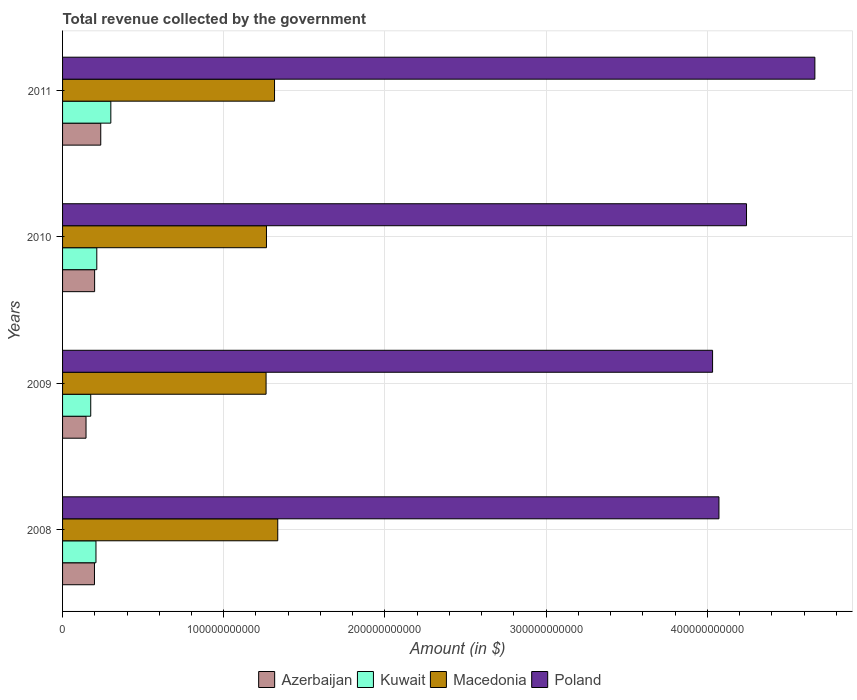How many different coloured bars are there?
Your answer should be very brief. 4. Are the number of bars per tick equal to the number of legend labels?
Give a very brief answer. Yes. Are the number of bars on each tick of the Y-axis equal?
Your answer should be compact. Yes. How many bars are there on the 1st tick from the bottom?
Provide a succinct answer. 4. In how many cases, is the number of bars for a given year not equal to the number of legend labels?
Offer a very short reply. 0. What is the total revenue collected by the government in Poland in 2010?
Your answer should be compact. 4.24e+11. Across all years, what is the maximum total revenue collected by the government in Kuwait?
Give a very brief answer. 2.99e+1. Across all years, what is the minimum total revenue collected by the government in Kuwait?
Make the answer very short. 1.75e+1. In which year was the total revenue collected by the government in Azerbaijan maximum?
Make the answer very short. 2011. What is the total total revenue collected by the government in Kuwait in the graph?
Provide a short and direct response. 8.94e+1. What is the difference between the total revenue collected by the government in Kuwait in 2009 and that in 2011?
Offer a terse response. -1.25e+1. What is the difference between the total revenue collected by the government in Kuwait in 2009 and the total revenue collected by the government in Macedonia in 2011?
Ensure brevity in your answer.  -1.14e+11. What is the average total revenue collected by the government in Azerbaijan per year?
Offer a terse response. 1.95e+1. In the year 2009, what is the difference between the total revenue collected by the government in Kuwait and total revenue collected by the government in Azerbaijan?
Give a very brief answer. 2.92e+09. In how many years, is the total revenue collected by the government in Macedonia greater than 100000000000 $?
Ensure brevity in your answer.  4. What is the ratio of the total revenue collected by the government in Kuwait in 2009 to that in 2011?
Offer a terse response. 0.58. Is the total revenue collected by the government in Poland in 2008 less than that in 2011?
Your answer should be very brief. Yes. What is the difference between the highest and the second highest total revenue collected by the government in Macedonia?
Your answer should be compact. 1.99e+09. What is the difference between the highest and the lowest total revenue collected by the government in Poland?
Your answer should be very brief. 6.35e+1. Is the sum of the total revenue collected by the government in Poland in 2010 and 2011 greater than the maximum total revenue collected by the government in Macedonia across all years?
Offer a terse response. Yes. What does the 4th bar from the top in 2010 represents?
Ensure brevity in your answer.  Azerbaijan. What does the 2nd bar from the bottom in 2009 represents?
Offer a terse response. Kuwait. Is it the case that in every year, the sum of the total revenue collected by the government in Poland and total revenue collected by the government in Azerbaijan is greater than the total revenue collected by the government in Kuwait?
Give a very brief answer. Yes. How many bars are there?
Make the answer very short. 16. How many years are there in the graph?
Make the answer very short. 4. What is the difference between two consecutive major ticks on the X-axis?
Make the answer very short. 1.00e+11. Are the values on the major ticks of X-axis written in scientific E-notation?
Ensure brevity in your answer.  No. Does the graph contain any zero values?
Give a very brief answer. No. Does the graph contain grids?
Give a very brief answer. Yes. Where does the legend appear in the graph?
Provide a short and direct response. Bottom center. How are the legend labels stacked?
Give a very brief answer. Horizontal. What is the title of the graph?
Give a very brief answer. Total revenue collected by the government. What is the label or title of the X-axis?
Provide a succinct answer. Amount (in $). What is the Amount (in $) of Azerbaijan in 2008?
Keep it short and to the point. 1.98e+1. What is the Amount (in $) in Kuwait in 2008?
Your response must be concise. 2.07e+1. What is the Amount (in $) of Macedonia in 2008?
Offer a very short reply. 1.34e+11. What is the Amount (in $) in Poland in 2008?
Provide a succinct answer. 4.07e+11. What is the Amount (in $) of Azerbaijan in 2009?
Provide a short and direct response. 1.46e+1. What is the Amount (in $) of Kuwait in 2009?
Offer a terse response. 1.75e+1. What is the Amount (in $) in Macedonia in 2009?
Offer a terse response. 1.26e+11. What is the Amount (in $) of Poland in 2009?
Offer a terse response. 4.03e+11. What is the Amount (in $) in Azerbaijan in 2010?
Give a very brief answer. 1.99e+1. What is the Amount (in $) in Kuwait in 2010?
Offer a very short reply. 2.12e+1. What is the Amount (in $) in Macedonia in 2010?
Ensure brevity in your answer.  1.27e+11. What is the Amount (in $) in Poland in 2010?
Provide a succinct answer. 4.24e+11. What is the Amount (in $) in Azerbaijan in 2011?
Your response must be concise. 2.37e+1. What is the Amount (in $) of Kuwait in 2011?
Make the answer very short. 2.99e+1. What is the Amount (in $) in Macedonia in 2011?
Provide a succinct answer. 1.32e+11. What is the Amount (in $) in Poland in 2011?
Make the answer very short. 4.67e+11. Across all years, what is the maximum Amount (in $) in Azerbaijan?
Give a very brief answer. 2.37e+1. Across all years, what is the maximum Amount (in $) in Kuwait?
Your answer should be very brief. 2.99e+1. Across all years, what is the maximum Amount (in $) in Macedonia?
Your answer should be very brief. 1.34e+11. Across all years, what is the maximum Amount (in $) of Poland?
Your response must be concise. 4.67e+11. Across all years, what is the minimum Amount (in $) in Azerbaijan?
Ensure brevity in your answer.  1.46e+1. Across all years, what is the minimum Amount (in $) of Kuwait?
Keep it short and to the point. 1.75e+1. Across all years, what is the minimum Amount (in $) of Macedonia?
Your answer should be very brief. 1.26e+11. Across all years, what is the minimum Amount (in $) of Poland?
Your answer should be compact. 4.03e+11. What is the total Amount (in $) of Azerbaijan in the graph?
Provide a short and direct response. 7.79e+1. What is the total Amount (in $) in Kuwait in the graph?
Provide a short and direct response. 8.94e+1. What is the total Amount (in $) in Macedonia in the graph?
Offer a very short reply. 5.18e+11. What is the total Amount (in $) of Poland in the graph?
Your answer should be compact. 1.70e+12. What is the difference between the Amount (in $) of Azerbaijan in 2008 and that in 2009?
Offer a very short reply. 5.23e+09. What is the difference between the Amount (in $) in Kuwait in 2008 and that in 2009?
Offer a terse response. 3.25e+09. What is the difference between the Amount (in $) of Macedonia in 2008 and that in 2009?
Your answer should be compact. 7.24e+09. What is the difference between the Amount (in $) of Poland in 2008 and that in 2009?
Ensure brevity in your answer.  3.95e+09. What is the difference between the Amount (in $) in Azerbaijan in 2008 and that in 2010?
Provide a short and direct response. -9.75e+07. What is the difference between the Amount (in $) in Kuwait in 2008 and that in 2010?
Provide a succinct answer. -5.14e+08. What is the difference between the Amount (in $) in Macedonia in 2008 and that in 2010?
Give a very brief answer. 7.00e+09. What is the difference between the Amount (in $) in Poland in 2008 and that in 2010?
Ensure brevity in your answer.  -1.71e+1. What is the difference between the Amount (in $) in Azerbaijan in 2008 and that in 2011?
Make the answer very short. -3.90e+09. What is the difference between the Amount (in $) of Kuwait in 2008 and that in 2011?
Give a very brief answer. -9.22e+09. What is the difference between the Amount (in $) of Macedonia in 2008 and that in 2011?
Your answer should be very brief. 1.99e+09. What is the difference between the Amount (in $) of Poland in 2008 and that in 2011?
Provide a succinct answer. -5.95e+1. What is the difference between the Amount (in $) in Azerbaijan in 2009 and that in 2010?
Keep it short and to the point. -5.33e+09. What is the difference between the Amount (in $) of Kuwait in 2009 and that in 2010?
Your answer should be very brief. -3.77e+09. What is the difference between the Amount (in $) of Macedonia in 2009 and that in 2010?
Keep it short and to the point. -2.45e+08. What is the difference between the Amount (in $) of Poland in 2009 and that in 2010?
Ensure brevity in your answer.  -2.11e+1. What is the difference between the Amount (in $) of Azerbaijan in 2009 and that in 2011?
Provide a succinct answer. -9.13e+09. What is the difference between the Amount (in $) in Kuwait in 2009 and that in 2011?
Make the answer very short. -1.25e+1. What is the difference between the Amount (in $) of Macedonia in 2009 and that in 2011?
Keep it short and to the point. -5.25e+09. What is the difference between the Amount (in $) of Poland in 2009 and that in 2011?
Your answer should be very brief. -6.35e+1. What is the difference between the Amount (in $) in Azerbaijan in 2010 and that in 2011?
Your answer should be very brief. -3.80e+09. What is the difference between the Amount (in $) in Kuwait in 2010 and that in 2011?
Keep it short and to the point. -8.70e+09. What is the difference between the Amount (in $) of Macedonia in 2010 and that in 2011?
Provide a short and direct response. -5.01e+09. What is the difference between the Amount (in $) in Poland in 2010 and that in 2011?
Offer a terse response. -4.24e+1. What is the difference between the Amount (in $) in Azerbaijan in 2008 and the Amount (in $) in Kuwait in 2009?
Your answer should be compact. 2.32e+09. What is the difference between the Amount (in $) in Azerbaijan in 2008 and the Amount (in $) in Macedonia in 2009?
Give a very brief answer. -1.06e+11. What is the difference between the Amount (in $) in Azerbaijan in 2008 and the Amount (in $) in Poland in 2009?
Offer a very short reply. -3.83e+11. What is the difference between the Amount (in $) of Kuwait in 2008 and the Amount (in $) of Macedonia in 2009?
Keep it short and to the point. -1.06e+11. What is the difference between the Amount (in $) of Kuwait in 2008 and the Amount (in $) of Poland in 2009?
Ensure brevity in your answer.  -3.83e+11. What is the difference between the Amount (in $) of Macedonia in 2008 and the Amount (in $) of Poland in 2009?
Give a very brief answer. -2.70e+11. What is the difference between the Amount (in $) of Azerbaijan in 2008 and the Amount (in $) of Kuwait in 2010?
Your answer should be compact. -1.45e+09. What is the difference between the Amount (in $) of Azerbaijan in 2008 and the Amount (in $) of Macedonia in 2010?
Offer a terse response. -1.07e+11. What is the difference between the Amount (in $) of Azerbaijan in 2008 and the Amount (in $) of Poland in 2010?
Provide a succinct answer. -4.05e+11. What is the difference between the Amount (in $) of Kuwait in 2008 and the Amount (in $) of Macedonia in 2010?
Your response must be concise. -1.06e+11. What is the difference between the Amount (in $) of Kuwait in 2008 and the Amount (in $) of Poland in 2010?
Ensure brevity in your answer.  -4.04e+11. What is the difference between the Amount (in $) of Macedonia in 2008 and the Amount (in $) of Poland in 2010?
Provide a succinct answer. -2.91e+11. What is the difference between the Amount (in $) in Azerbaijan in 2008 and the Amount (in $) in Kuwait in 2011?
Your answer should be very brief. -1.02e+1. What is the difference between the Amount (in $) in Azerbaijan in 2008 and the Amount (in $) in Macedonia in 2011?
Give a very brief answer. -1.12e+11. What is the difference between the Amount (in $) in Azerbaijan in 2008 and the Amount (in $) in Poland in 2011?
Your answer should be compact. -4.47e+11. What is the difference between the Amount (in $) in Kuwait in 2008 and the Amount (in $) in Macedonia in 2011?
Give a very brief answer. -1.11e+11. What is the difference between the Amount (in $) in Kuwait in 2008 and the Amount (in $) in Poland in 2011?
Make the answer very short. -4.46e+11. What is the difference between the Amount (in $) of Macedonia in 2008 and the Amount (in $) of Poland in 2011?
Provide a short and direct response. -3.33e+11. What is the difference between the Amount (in $) of Azerbaijan in 2009 and the Amount (in $) of Kuwait in 2010?
Ensure brevity in your answer.  -6.68e+09. What is the difference between the Amount (in $) of Azerbaijan in 2009 and the Amount (in $) of Macedonia in 2010?
Keep it short and to the point. -1.12e+11. What is the difference between the Amount (in $) in Azerbaijan in 2009 and the Amount (in $) in Poland in 2010?
Provide a short and direct response. -4.10e+11. What is the difference between the Amount (in $) of Kuwait in 2009 and the Amount (in $) of Macedonia in 2010?
Provide a succinct answer. -1.09e+11. What is the difference between the Amount (in $) in Kuwait in 2009 and the Amount (in $) in Poland in 2010?
Your answer should be compact. -4.07e+11. What is the difference between the Amount (in $) in Macedonia in 2009 and the Amount (in $) in Poland in 2010?
Provide a succinct answer. -2.98e+11. What is the difference between the Amount (in $) in Azerbaijan in 2009 and the Amount (in $) in Kuwait in 2011?
Offer a terse response. -1.54e+1. What is the difference between the Amount (in $) of Azerbaijan in 2009 and the Amount (in $) of Macedonia in 2011?
Your answer should be very brief. -1.17e+11. What is the difference between the Amount (in $) of Azerbaijan in 2009 and the Amount (in $) of Poland in 2011?
Offer a very short reply. -4.52e+11. What is the difference between the Amount (in $) in Kuwait in 2009 and the Amount (in $) in Macedonia in 2011?
Offer a terse response. -1.14e+11. What is the difference between the Amount (in $) in Kuwait in 2009 and the Amount (in $) in Poland in 2011?
Give a very brief answer. -4.49e+11. What is the difference between the Amount (in $) of Macedonia in 2009 and the Amount (in $) of Poland in 2011?
Make the answer very short. -3.40e+11. What is the difference between the Amount (in $) of Azerbaijan in 2010 and the Amount (in $) of Kuwait in 2011?
Your response must be concise. -1.01e+1. What is the difference between the Amount (in $) of Azerbaijan in 2010 and the Amount (in $) of Macedonia in 2011?
Offer a very short reply. -1.12e+11. What is the difference between the Amount (in $) of Azerbaijan in 2010 and the Amount (in $) of Poland in 2011?
Offer a very short reply. -4.47e+11. What is the difference between the Amount (in $) in Kuwait in 2010 and the Amount (in $) in Macedonia in 2011?
Provide a short and direct response. -1.10e+11. What is the difference between the Amount (in $) in Kuwait in 2010 and the Amount (in $) in Poland in 2011?
Provide a succinct answer. -4.46e+11. What is the difference between the Amount (in $) of Macedonia in 2010 and the Amount (in $) of Poland in 2011?
Offer a terse response. -3.40e+11. What is the average Amount (in $) of Azerbaijan per year?
Your answer should be compact. 1.95e+1. What is the average Amount (in $) of Kuwait per year?
Ensure brevity in your answer.  2.23e+1. What is the average Amount (in $) of Macedonia per year?
Keep it short and to the point. 1.29e+11. What is the average Amount (in $) in Poland per year?
Your answer should be very brief. 4.25e+11. In the year 2008, what is the difference between the Amount (in $) of Azerbaijan and Amount (in $) of Kuwait?
Give a very brief answer. -9.37e+08. In the year 2008, what is the difference between the Amount (in $) in Azerbaijan and Amount (in $) in Macedonia?
Keep it short and to the point. -1.14e+11. In the year 2008, what is the difference between the Amount (in $) of Azerbaijan and Amount (in $) of Poland?
Offer a very short reply. -3.87e+11. In the year 2008, what is the difference between the Amount (in $) of Kuwait and Amount (in $) of Macedonia?
Your answer should be very brief. -1.13e+11. In the year 2008, what is the difference between the Amount (in $) of Kuwait and Amount (in $) of Poland?
Provide a succinct answer. -3.87e+11. In the year 2008, what is the difference between the Amount (in $) of Macedonia and Amount (in $) of Poland?
Ensure brevity in your answer.  -2.74e+11. In the year 2009, what is the difference between the Amount (in $) in Azerbaijan and Amount (in $) in Kuwait?
Ensure brevity in your answer.  -2.92e+09. In the year 2009, what is the difference between the Amount (in $) in Azerbaijan and Amount (in $) in Macedonia?
Ensure brevity in your answer.  -1.12e+11. In the year 2009, what is the difference between the Amount (in $) of Azerbaijan and Amount (in $) of Poland?
Keep it short and to the point. -3.89e+11. In the year 2009, what is the difference between the Amount (in $) of Kuwait and Amount (in $) of Macedonia?
Ensure brevity in your answer.  -1.09e+11. In the year 2009, what is the difference between the Amount (in $) of Kuwait and Amount (in $) of Poland?
Keep it short and to the point. -3.86e+11. In the year 2009, what is the difference between the Amount (in $) of Macedonia and Amount (in $) of Poland?
Keep it short and to the point. -2.77e+11. In the year 2010, what is the difference between the Amount (in $) of Azerbaijan and Amount (in $) of Kuwait?
Make the answer very short. -1.35e+09. In the year 2010, what is the difference between the Amount (in $) of Azerbaijan and Amount (in $) of Macedonia?
Provide a succinct answer. -1.07e+11. In the year 2010, what is the difference between the Amount (in $) in Azerbaijan and Amount (in $) in Poland?
Give a very brief answer. -4.04e+11. In the year 2010, what is the difference between the Amount (in $) of Kuwait and Amount (in $) of Macedonia?
Provide a succinct answer. -1.05e+11. In the year 2010, what is the difference between the Amount (in $) of Kuwait and Amount (in $) of Poland?
Give a very brief answer. -4.03e+11. In the year 2010, what is the difference between the Amount (in $) in Macedonia and Amount (in $) in Poland?
Give a very brief answer. -2.98e+11. In the year 2011, what is the difference between the Amount (in $) of Azerbaijan and Amount (in $) of Kuwait?
Your answer should be very brief. -6.26e+09. In the year 2011, what is the difference between the Amount (in $) of Azerbaijan and Amount (in $) of Macedonia?
Ensure brevity in your answer.  -1.08e+11. In the year 2011, what is the difference between the Amount (in $) of Azerbaijan and Amount (in $) of Poland?
Provide a succinct answer. -4.43e+11. In the year 2011, what is the difference between the Amount (in $) of Kuwait and Amount (in $) of Macedonia?
Offer a terse response. -1.02e+11. In the year 2011, what is the difference between the Amount (in $) in Kuwait and Amount (in $) in Poland?
Give a very brief answer. -4.37e+11. In the year 2011, what is the difference between the Amount (in $) of Macedonia and Amount (in $) of Poland?
Your answer should be compact. -3.35e+11. What is the ratio of the Amount (in $) in Azerbaijan in 2008 to that in 2009?
Your answer should be very brief. 1.36. What is the ratio of the Amount (in $) of Kuwait in 2008 to that in 2009?
Keep it short and to the point. 1.19. What is the ratio of the Amount (in $) of Macedonia in 2008 to that in 2009?
Make the answer very short. 1.06. What is the ratio of the Amount (in $) of Poland in 2008 to that in 2009?
Keep it short and to the point. 1.01. What is the ratio of the Amount (in $) in Kuwait in 2008 to that in 2010?
Offer a very short reply. 0.98. What is the ratio of the Amount (in $) of Macedonia in 2008 to that in 2010?
Keep it short and to the point. 1.06. What is the ratio of the Amount (in $) in Poland in 2008 to that in 2010?
Your answer should be compact. 0.96. What is the ratio of the Amount (in $) in Azerbaijan in 2008 to that in 2011?
Offer a terse response. 0.84. What is the ratio of the Amount (in $) of Kuwait in 2008 to that in 2011?
Make the answer very short. 0.69. What is the ratio of the Amount (in $) of Macedonia in 2008 to that in 2011?
Offer a very short reply. 1.02. What is the ratio of the Amount (in $) of Poland in 2008 to that in 2011?
Keep it short and to the point. 0.87. What is the ratio of the Amount (in $) in Azerbaijan in 2009 to that in 2010?
Your answer should be compact. 0.73. What is the ratio of the Amount (in $) in Kuwait in 2009 to that in 2010?
Provide a short and direct response. 0.82. What is the ratio of the Amount (in $) in Poland in 2009 to that in 2010?
Offer a very short reply. 0.95. What is the ratio of the Amount (in $) in Azerbaijan in 2009 to that in 2011?
Offer a terse response. 0.61. What is the ratio of the Amount (in $) in Kuwait in 2009 to that in 2011?
Offer a terse response. 0.58. What is the ratio of the Amount (in $) in Macedonia in 2009 to that in 2011?
Your answer should be compact. 0.96. What is the ratio of the Amount (in $) in Poland in 2009 to that in 2011?
Provide a short and direct response. 0.86. What is the ratio of the Amount (in $) in Azerbaijan in 2010 to that in 2011?
Keep it short and to the point. 0.84. What is the ratio of the Amount (in $) in Kuwait in 2010 to that in 2011?
Ensure brevity in your answer.  0.71. What is the ratio of the Amount (in $) of Macedonia in 2010 to that in 2011?
Make the answer very short. 0.96. What is the ratio of the Amount (in $) of Poland in 2010 to that in 2011?
Offer a very short reply. 0.91. What is the difference between the highest and the second highest Amount (in $) in Azerbaijan?
Your response must be concise. 3.80e+09. What is the difference between the highest and the second highest Amount (in $) in Kuwait?
Your response must be concise. 8.70e+09. What is the difference between the highest and the second highest Amount (in $) of Macedonia?
Offer a terse response. 1.99e+09. What is the difference between the highest and the second highest Amount (in $) of Poland?
Offer a very short reply. 4.24e+1. What is the difference between the highest and the lowest Amount (in $) in Azerbaijan?
Make the answer very short. 9.13e+09. What is the difference between the highest and the lowest Amount (in $) of Kuwait?
Provide a succinct answer. 1.25e+1. What is the difference between the highest and the lowest Amount (in $) in Macedonia?
Your response must be concise. 7.24e+09. What is the difference between the highest and the lowest Amount (in $) of Poland?
Keep it short and to the point. 6.35e+1. 